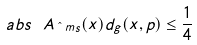<formula> <loc_0><loc_0><loc_500><loc_500>\ a b s { \ A _ { \hat { \ } m s } } ( x ) d _ { g } ( x , p ) \leq \frac { 1 } { 4 }</formula> 